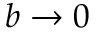<formula> <loc_0><loc_0><loc_500><loc_500>b \rightarrow 0</formula> 